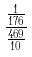<formula> <loc_0><loc_0><loc_500><loc_500>\frac { \frac { 1 } { 1 7 6 } } { \frac { 4 6 9 } { 1 0 } }</formula> 